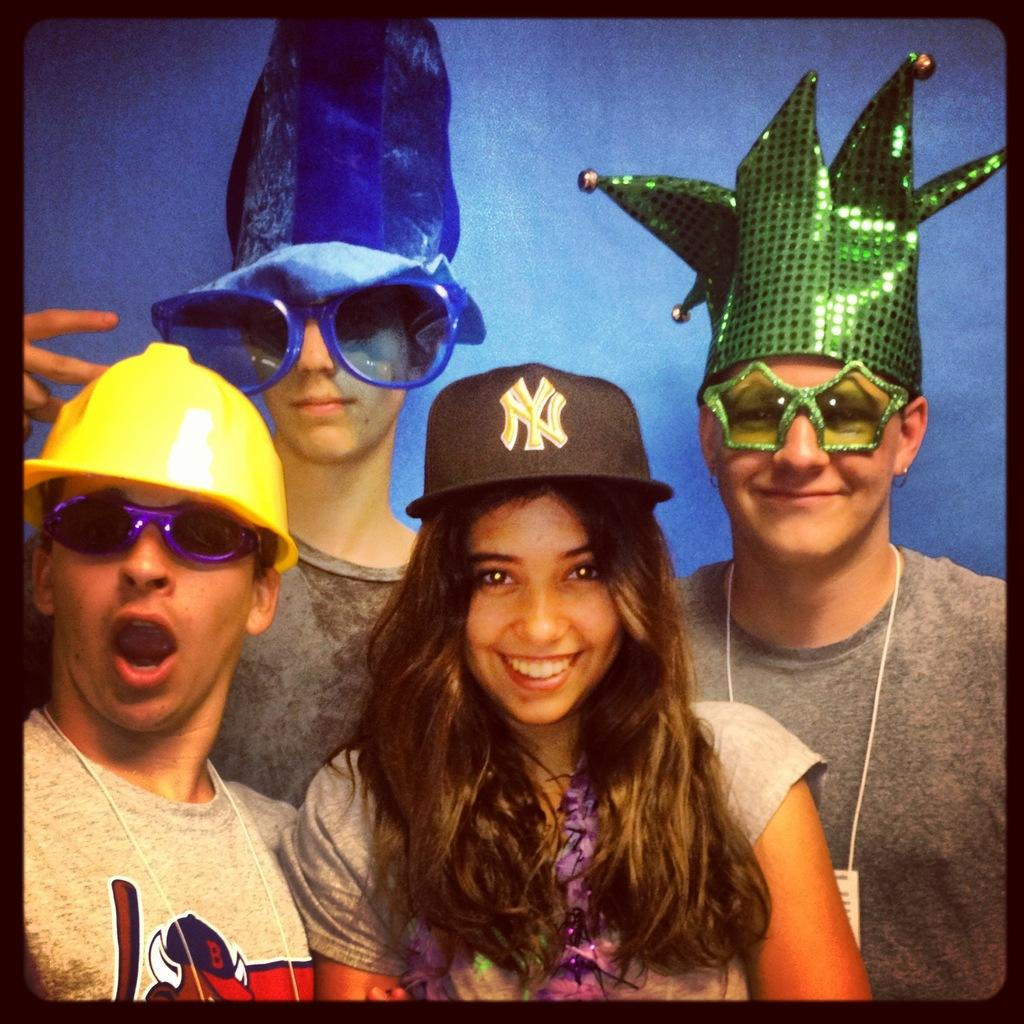How many people are in the image? There are four people in the image. What are the people wearing on their heads? Each person is wearing a cap. What else are the people wearing in the image? Each person is also wearing goggles. What is the expression on the people's faces? The people are smiling in the image. What color is the background of the image? The background of the image is blue. What type of tub can be seen in the image? There is no tub present in the image. How is the string being used by the people in the image? There is no string visible in the image. 